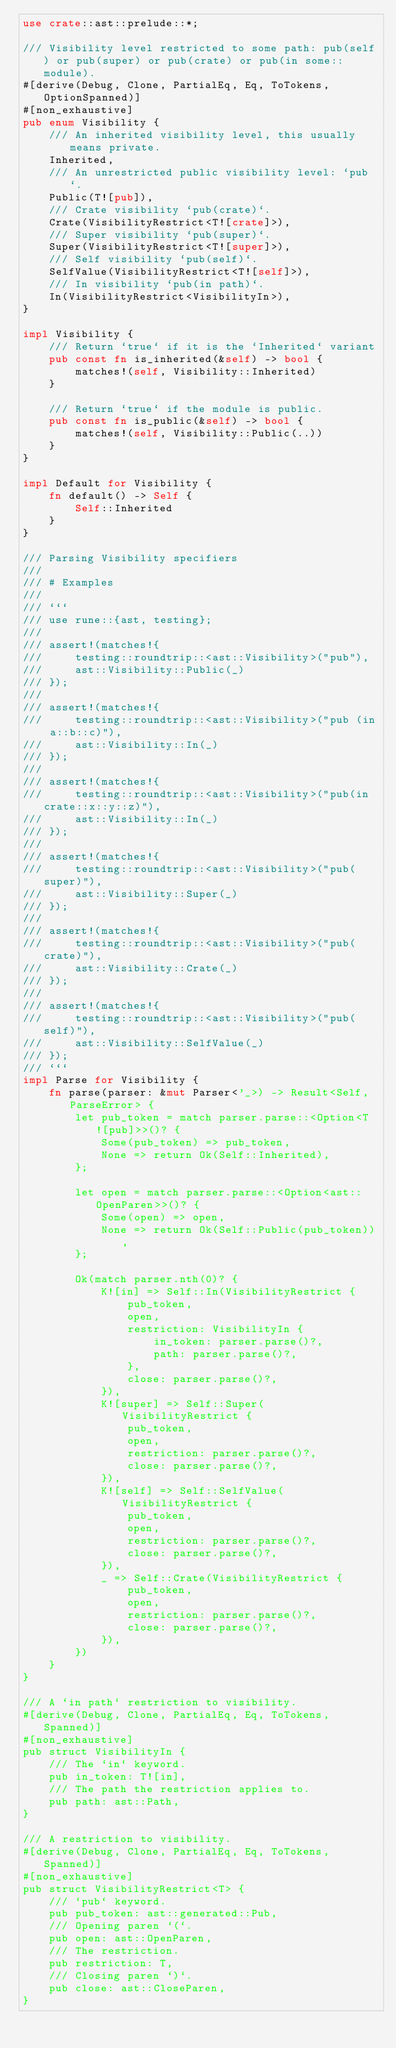Convert code to text. <code><loc_0><loc_0><loc_500><loc_500><_Rust_>use crate::ast::prelude::*;

/// Visibility level restricted to some path: pub(self) or pub(super) or pub(crate) or pub(in some::module).
#[derive(Debug, Clone, PartialEq, Eq, ToTokens, OptionSpanned)]
#[non_exhaustive]
pub enum Visibility {
    /// An inherited visibility level, this usually means private.
    Inherited,
    /// An unrestricted public visibility level: `pub`.
    Public(T![pub]),
    /// Crate visibility `pub(crate)`.
    Crate(VisibilityRestrict<T![crate]>),
    /// Super visibility `pub(super)`.
    Super(VisibilityRestrict<T![super]>),
    /// Self visibility `pub(self)`.
    SelfValue(VisibilityRestrict<T![self]>),
    /// In visibility `pub(in path)`.
    In(VisibilityRestrict<VisibilityIn>),
}

impl Visibility {
    /// Return `true` if it is the `Inherited` variant
    pub const fn is_inherited(&self) -> bool {
        matches!(self, Visibility::Inherited)
    }

    /// Return `true` if the module is public.
    pub const fn is_public(&self) -> bool {
        matches!(self, Visibility::Public(..))
    }
}

impl Default for Visibility {
    fn default() -> Self {
        Self::Inherited
    }
}

/// Parsing Visibility specifiers
///
/// # Examples
///
/// ```
/// use rune::{ast, testing};
///
/// assert!(matches!{
///     testing::roundtrip::<ast::Visibility>("pub"),
///     ast::Visibility::Public(_)
/// });
///
/// assert!(matches!{
///     testing::roundtrip::<ast::Visibility>("pub (in a::b::c)"),
///     ast::Visibility::In(_)
/// });
///
/// assert!(matches!{
///     testing::roundtrip::<ast::Visibility>("pub(in crate::x::y::z)"),
///     ast::Visibility::In(_)
/// });
///
/// assert!(matches!{
///     testing::roundtrip::<ast::Visibility>("pub(super)"),
///     ast::Visibility::Super(_)
/// });
///
/// assert!(matches!{
///     testing::roundtrip::<ast::Visibility>("pub(crate)"),
///     ast::Visibility::Crate(_)
/// });
///
/// assert!(matches!{
///     testing::roundtrip::<ast::Visibility>("pub(self)"),
///     ast::Visibility::SelfValue(_)
/// });
/// ```
impl Parse for Visibility {
    fn parse(parser: &mut Parser<'_>) -> Result<Self, ParseError> {
        let pub_token = match parser.parse::<Option<T![pub]>>()? {
            Some(pub_token) => pub_token,
            None => return Ok(Self::Inherited),
        };

        let open = match parser.parse::<Option<ast::OpenParen>>()? {
            Some(open) => open,
            None => return Ok(Self::Public(pub_token)),
        };

        Ok(match parser.nth(0)? {
            K![in] => Self::In(VisibilityRestrict {
                pub_token,
                open,
                restriction: VisibilityIn {
                    in_token: parser.parse()?,
                    path: parser.parse()?,
                },
                close: parser.parse()?,
            }),
            K![super] => Self::Super(VisibilityRestrict {
                pub_token,
                open,
                restriction: parser.parse()?,
                close: parser.parse()?,
            }),
            K![self] => Self::SelfValue(VisibilityRestrict {
                pub_token,
                open,
                restriction: parser.parse()?,
                close: parser.parse()?,
            }),
            _ => Self::Crate(VisibilityRestrict {
                pub_token,
                open,
                restriction: parser.parse()?,
                close: parser.parse()?,
            }),
        })
    }
}

/// A `in path` restriction to visibility.
#[derive(Debug, Clone, PartialEq, Eq, ToTokens, Spanned)]
#[non_exhaustive]
pub struct VisibilityIn {
    /// The `in` keyword.
    pub in_token: T![in],
    /// The path the restriction applies to.
    pub path: ast::Path,
}

/// A restriction to visibility.
#[derive(Debug, Clone, PartialEq, Eq, ToTokens, Spanned)]
#[non_exhaustive]
pub struct VisibilityRestrict<T> {
    /// `pub` keyword.
    pub pub_token: ast::generated::Pub,
    /// Opening paren `(`.
    pub open: ast::OpenParen,
    /// The restriction.
    pub restriction: T,
    /// Closing paren `)`.
    pub close: ast::CloseParen,
}
</code> 